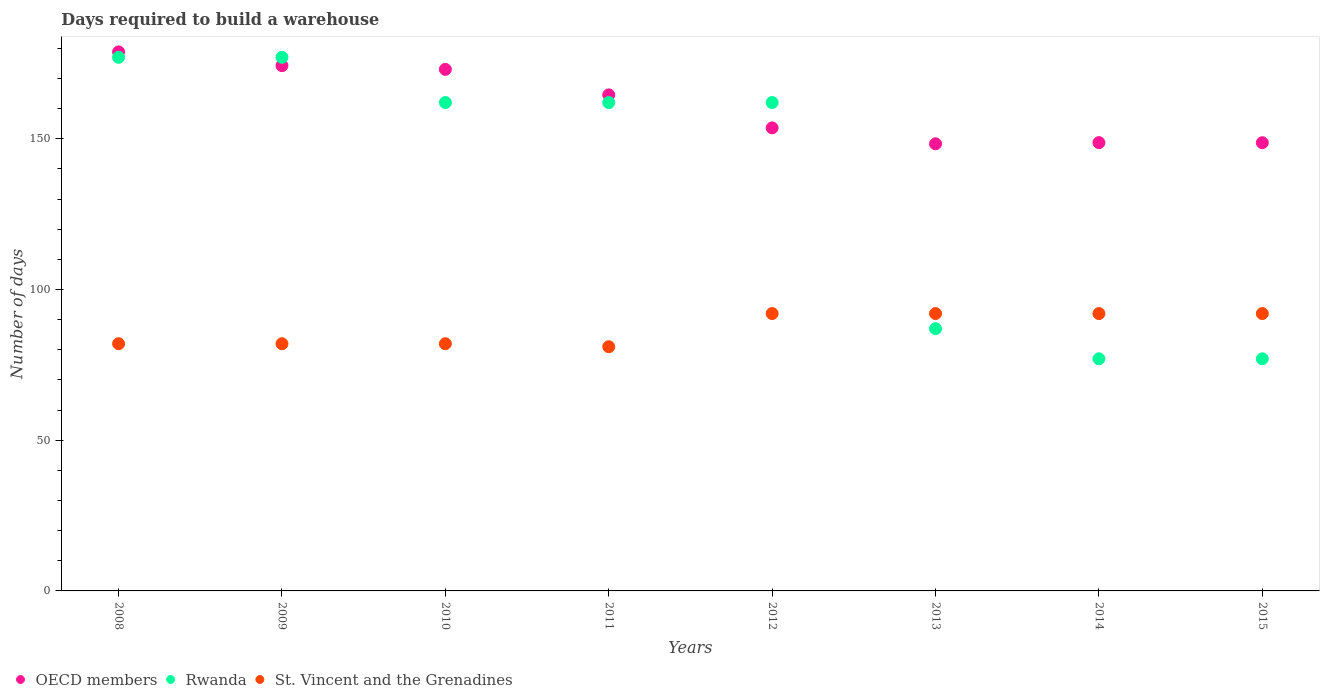Is the number of dotlines equal to the number of legend labels?
Your answer should be very brief. Yes. What is the days required to build a warehouse in in Rwanda in 2010?
Your answer should be compact. 162. Across all years, what is the maximum days required to build a warehouse in in OECD members?
Give a very brief answer. 178.79. Across all years, what is the minimum days required to build a warehouse in in St. Vincent and the Grenadines?
Keep it short and to the point. 81. In which year was the days required to build a warehouse in in OECD members maximum?
Provide a short and direct response. 2008. What is the total days required to build a warehouse in in St. Vincent and the Grenadines in the graph?
Make the answer very short. 695. What is the difference between the days required to build a warehouse in in St. Vincent and the Grenadines in 2009 and that in 2014?
Keep it short and to the point. -10. What is the difference between the days required to build a warehouse in in St. Vincent and the Grenadines in 2015 and the days required to build a warehouse in in OECD members in 2009?
Your response must be concise. -82.24. What is the average days required to build a warehouse in in OECD members per year?
Provide a short and direct response. 161.23. In the year 2009, what is the difference between the days required to build a warehouse in in St. Vincent and the Grenadines and days required to build a warehouse in in Rwanda?
Keep it short and to the point. -95. What is the ratio of the days required to build a warehouse in in Rwanda in 2008 to that in 2014?
Ensure brevity in your answer.  2.3. What is the difference between the highest and the second highest days required to build a warehouse in in OECD members?
Provide a short and direct response. 4.55. What is the difference between the highest and the lowest days required to build a warehouse in in Rwanda?
Offer a very short reply. 100. Is the sum of the days required to build a warehouse in in St. Vincent and the Grenadines in 2013 and 2015 greater than the maximum days required to build a warehouse in in OECD members across all years?
Provide a short and direct response. Yes. Does the days required to build a warehouse in in St. Vincent and the Grenadines monotonically increase over the years?
Your answer should be very brief. No. Is the days required to build a warehouse in in St. Vincent and the Grenadines strictly greater than the days required to build a warehouse in in Rwanda over the years?
Your answer should be very brief. No. How many dotlines are there?
Give a very brief answer. 3. What is the difference between two consecutive major ticks on the Y-axis?
Your answer should be compact. 50. Are the values on the major ticks of Y-axis written in scientific E-notation?
Your answer should be very brief. No. Where does the legend appear in the graph?
Offer a very short reply. Bottom left. How many legend labels are there?
Ensure brevity in your answer.  3. How are the legend labels stacked?
Provide a short and direct response. Horizontal. What is the title of the graph?
Your answer should be very brief. Days required to build a warehouse. Does "Micronesia" appear as one of the legend labels in the graph?
Your answer should be very brief. No. What is the label or title of the X-axis?
Your answer should be very brief. Years. What is the label or title of the Y-axis?
Your response must be concise. Number of days. What is the Number of days of OECD members in 2008?
Your response must be concise. 178.79. What is the Number of days in Rwanda in 2008?
Keep it short and to the point. 177. What is the Number of days of OECD members in 2009?
Ensure brevity in your answer.  174.24. What is the Number of days of Rwanda in 2009?
Make the answer very short. 177. What is the Number of days of OECD members in 2010?
Offer a very short reply. 173. What is the Number of days of Rwanda in 2010?
Provide a succinct answer. 162. What is the Number of days in St. Vincent and the Grenadines in 2010?
Offer a terse response. 82. What is the Number of days of OECD members in 2011?
Ensure brevity in your answer.  164.55. What is the Number of days of Rwanda in 2011?
Your response must be concise. 162. What is the Number of days in St. Vincent and the Grenadines in 2011?
Your response must be concise. 81. What is the Number of days in OECD members in 2012?
Your answer should be compact. 153.6. What is the Number of days in Rwanda in 2012?
Offer a very short reply. 162. What is the Number of days of St. Vincent and the Grenadines in 2012?
Your response must be concise. 92. What is the Number of days of OECD members in 2013?
Your answer should be very brief. 148.31. What is the Number of days of Rwanda in 2013?
Keep it short and to the point. 87. What is the Number of days in St. Vincent and the Grenadines in 2013?
Keep it short and to the point. 92. What is the Number of days in OECD members in 2014?
Give a very brief answer. 148.71. What is the Number of days of St. Vincent and the Grenadines in 2014?
Make the answer very short. 92. What is the Number of days of OECD members in 2015?
Provide a short and direct response. 148.68. What is the Number of days of St. Vincent and the Grenadines in 2015?
Offer a very short reply. 92. Across all years, what is the maximum Number of days of OECD members?
Ensure brevity in your answer.  178.79. Across all years, what is the maximum Number of days of Rwanda?
Keep it short and to the point. 177. Across all years, what is the maximum Number of days of St. Vincent and the Grenadines?
Your answer should be compact. 92. Across all years, what is the minimum Number of days in OECD members?
Your answer should be compact. 148.31. Across all years, what is the minimum Number of days in St. Vincent and the Grenadines?
Provide a succinct answer. 81. What is the total Number of days in OECD members in the graph?
Your answer should be very brief. 1289.87. What is the total Number of days in Rwanda in the graph?
Ensure brevity in your answer.  1081. What is the total Number of days of St. Vincent and the Grenadines in the graph?
Make the answer very short. 695. What is the difference between the Number of days of OECD members in 2008 and that in 2009?
Make the answer very short. 4.55. What is the difference between the Number of days of OECD members in 2008 and that in 2010?
Provide a short and direct response. 5.79. What is the difference between the Number of days in OECD members in 2008 and that in 2011?
Make the answer very short. 14.24. What is the difference between the Number of days of Rwanda in 2008 and that in 2011?
Keep it short and to the point. 15. What is the difference between the Number of days of OECD members in 2008 and that in 2012?
Offer a very short reply. 25.19. What is the difference between the Number of days of Rwanda in 2008 and that in 2012?
Your answer should be compact. 15. What is the difference between the Number of days in OECD members in 2008 and that in 2013?
Ensure brevity in your answer.  30.48. What is the difference between the Number of days of Rwanda in 2008 and that in 2013?
Make the answer very short. 90. What is the difference between the Number of days of St. Vincent and the Grenadines in 2008 and that in 2013?
Your response must be concise. -10. What is the difference between the Number of days of OECD members in 2008 and that in 2014?
Offer a terse response. 30.08. What is the difference between the Number of days in Rwanda in 2008 and that in 2014?
Make the answer very short. 100. What is the difference between the Number of days of St. Vincent and the Grenadines in 2008 and that in 2014?
Provide a succinct answer. -10. What is the difference between the Number of days in OECD members in 2008 and that in 2015?
Keep it short and to the point. 30.11. What is the difference between the Number of days of St. Vincent and the Grenadines in 2008 and that in 2015?
Offer a terse response. -10. What is the difference between the Number of days in OECD members in 2009 and that in 2010?
Give a very brief answer. 1.24. What is the difference between the Number of days of Rwanda in 2009 and that in 2010?
Your answer should be compact. 15. What is the difference between the Number of days of OECD members in 2009 and that in 2011?
Your answer should be compact. 9.69. What is the difference between the Number of days in Rwanda in 2009 and that in 2011?
Give a very brief answer. 15. What is the difference between the Number of days in St. Vincent and the Grenadines in 2009 and that in 2011?
Provide a short and direct response. 1. What is the difference between the Number of days in OECD members in 2009 and that in 2012?
Offer a very short reply. 20.65. What is the difference between the Number of days in St. Vincent and the Grenadines in 2009 and that in 2012?
Provide a short and direct response. -10. What is the difference between the Number of days in OECD members in 2009 and that in 2013?
Keep it short and to the point. 25.93. What is the difference between the Number of days in St. Vincent and the Grenadines in 2009 and that in 2013?
Provide a succinct answer. -10. What is the difference between the Number of days in OECD members in 2009 and that in 2014?
Offer a terse response. 25.54. What is the difference between the Number of days in Rwanda in 2009 and that in 2014?
Ensure brevity in your answer.  100. What is the difference between the Number of days of St. Vincent and the Grenadines in 2009 and that in 2014?
Ensure brevity in your answer.  -10. What is the difference between the Number of days of OECD members in 2009 and that in 2015?
Your answer should be very brief. 25.57. What is the difference between the Number of days of OECD members in 2010 and that in 2011?
Provide a short and direct response. 8.45. What is the difference between the Number of days of Rwanda in 2010 and that in 2011?
Your response must be concise. 0. What is the difference between the Number of days in St. Vincent and the Grenadines in 2010 and that in 2011?
Give a very brief answer. 1. What is the difference between the Number of days in OECD members in 2010 and that in 2012?
Your answer should be compact. 19.4. What is the difference between the Number of days in OECD members in 2010 and that in 2013?
Your answer should be very brief. 24.69. What is the difference between the Number of days in St. Vincent and the Grenadines in 2010 and that in 2013?
Ensure brevity in your answer.  -10. What is the difference between the Number of days of OECD members in 2010 and that in 2014?
Offer a very short reply. 24.29. What is the difference between the Number of days of Rwanda in 2010 and that in 2014?
Provide a succinct answer. 85. What is the difference between the Number of days in St. Vincent and the Grenadines in 2010 and that in 2014?
Your response must be concise. -10. What is the difference between the Number of days in OECD members in 2010 and that in 2015?
Your answer should be compact. 24.32. What is the difference between the Number of days of OECD members in 2011 and that in 2012?
Make the answer very short. 10.95. What is the difference between the Number of days of Rwanda in 2011 and that in 2012?
Make the answer very short. 0. What is the difference between the Number of days of OECD members in 2011 and that in 2013?
Give a very brief answer. 16.24. What is the difference between the Number of days of OECD members in 2011 and that in 2014?
Provide a succinct answer. 15.84. What is the difference between the Number of days of Rwanda in 2011 and that in 2014?
Provide a succinct answer. 85. What is the difference between the Number of days in OECD members in 2011 and that in 2015?
Provide a short and direct response. 15.87. What is the difference between the Number of days of St. Vincent and the Grenadines in 2011 and that in 2015?
Ensure brevity in your answer.  -11. What is the difference between the Number of days of OECD members in 2012 and that in 2013?
Your answer should be compact. 5.29. What is the difference between the Number of days of Rwanda in 2012 and that in 2013?
Keep it short and to the point. 75. What is the difference between the Number of days of OECD members in 2012 and that in 2014?
Your answer should be compact. 4.89. What is the difference between the Number of days in OECD members in 2012 and that in 2015?
Give a very brief answer. 4.92. What is the difference between the Number of days in Rwanda in 2012 and that in 2015?
Provide a short and direct response. 85. What is the difference between the Number of days in St. Vincent and the Grenadines in 2012 and that in 2015?
Keep it short and to the point. 0. What is the difference between the Number of days in OECD members in 2013 and that in 2014?
Your answer should be compact. -0.4. What is the difference between the Number of days in Rwanda in 2013 and that in 2014?
Make the answer very short. 10. What is the difference between the Number of days of OECD members in 2013 and that in 2015?
Your answer should be very brief. -0.37. What is the difference between the Number of days in Rwanda in 2013 and that in 2015?
Your response must be concise. 10. What is the difference between the Number of days of St. Vincent and the Grenadines in 2013 and that in 2015?
Make the answer very short. 0. What is the difference between the Number of days of OECD members in 2014 and that in 2015?
Give a very brief answer. 0.03. What is the difference between the Number of days in Rwanda in 2014 and that in 2015?
Your answer should be compact. 0. What is the difference between the Number of days in St. Vincent and the Grenadines in 2014 and that in 2015?
Make the answer very short. 0. What is the difference between the Number of days in OECD members in 2008 and the Number of days in Rwanda in 2009?
Offer a terse response. 1.79. What is the difference between the Number of days of OECD members in 2008 and the Number of days of St. Vincent and the Grenadines in 2009?
Offer a terse response. 96.79. What is the difference between the Number of days in OECD members in 2008 and the Number of days in Rwanda in 2010?
Ensure brevity in your answer.  16.79. What is the difference between the Number of days in OECD members in 2008 and the Number of days in St. Vincent and the Grenadines in 2010?
Your answer should be compact. 96.79. What is the difference between the Number of days of OECD members in 2008 and the Number of days of Rwanda in 2011?
Provide a short and direct response. 16.79. What is the difference between the Number of days of OECD members in 2008 and the Number of days of St. Vincent and the Grenadines in 2011?
Your response must be concise. 97.79. What is the difference between the Number of days of Rwanda in 2008 and the Number of days of St. Vincent and the Grenadines in 2011?
Your answer should be very brief. 96. What is the difference between the Number of days of OECD members in 2008 and the Number of days of Rwanda in 2012?
Your answer should be very brief. 16.79. What is the difference between the Number of days of OECD members in 2008 and the Number of days of St. Vincent and the Grenadines in 2012?
Your response must be concise. 86.79. What is the difference between the Number of days of Rwanda in 2008 and the Number of days of St. Vincent and the Grenadines in 2012?
Provide a short and direct response. 85. What is the difference between the Number of days of OECD members in 2008 and the Number of days of Rwanda in 2013?
Your answer should be very brief. 91.79. What is the difference between the Number of days in OECD members in 2008 and the Number of days in St. Vincent and the Grenadines in 2013?
Give a very brief answer. 86.79. What is the difference between the Number of days in OECD members in 2008 and the Number of days in Rwanda in 2014?
Provide a succinct answer. 101.79. What is the difference between the Number of days in OECD members in 2008 and the Number of days in St. Vincent and the Grenadines in 2014?
Give a very brief answer. 86.79. What is the difference between the Number of days of Rwanda in 2008 and the Number of days of St. Vincent and the Grenadines in 2014?
Give a very brief answer. 85. What is the difference between the Number of days of OECD members in 2008 and the Number of days of Rwanda in 2015?
Make the answer very short. 101.79. What is the difference between the Number of days in OECD members in 2008 and the Number of days in St. Vincent and the Grenadines in 2015?
Offer a very short reply. 86.79. What is the difference between the Number of days in Rwanda in 2008 and the Number of days in St. Vincent and the Grenadines in 2015?
Your answer should be very brief. 85. What is the difference between the Number of days of OECD members in 2009 and the Number of days of Rwanda in 2010?
Ensure brevity in your answer.  12.24. What is the difference between the Number of days of OECD members in 2009 and the Number of days of St. Vincent and the Grenadines in 2010?
Offer a terse response. 92.24. What is the difference between the Number of days of OECD members in 2009 and the Number of days of Rwanda in 2011?
Provide a short and direct response. 12.24. What is the difference between the Number of days of OECD members in 2009 and the Number of days of St. Vincent and the Grenadines in 2011?
Your response must be concise. 93.24. What is the difference between the Number of days in Rwanda in 2009 and the Number of days in St. Vincent and the Grenadines in 2011?
Keep it short and to the point. 96. What is the difference between the Number of days in OECD members in 2009 and the Number of days in Rwanda in 2012?
Provide a succinct answer. 12.24. What is the difference between the Number of days of OECD members in 2009 and the Number of days of St. Vincent and the Grenadines in 2012?
Your answer should be compact. 82.24. What is the difference between the Number of days of Rwanda in 2009 and the Number of days of St. Vincent and the Grenadines in 2012?
Provide a succinct answer. 85. What is the difference between the Number of days of OECD members in 2009 and the Number of days of Rwanda in 2013?
Ensure brevity in your answer.  87.24. What is the difference between the Number of days of OECD members in 2009 and the Number of days of St. Vincent and the Grenadines in 2013?
Your answer should be very brief. 82.24. What is the difference between the Number of days of Rwanda in 2009 and the Number of days of St. Vincent and the Grenadines in 2013?
Your answer should be compact. 85. What is the difference between the Number of days in OECD members in 2009 and the Number of days in Rwanda in 2014?
Provide a succinct answer. 97.24. What is the difference between the Number of days of OECD members in 2009 and the Number of days of St. Vincent and the Grenadines in 2014?
Your answer should be compact. 82.24. What is the difference between the Number of days in Rwanda in 2009 and the Number of days in St. Vincent and the Grenadines in 2014?
Offer a very short reply. 85. What is the difference between the Number of days in OECD members in 2009 and the Number of days in Rwanda in 2015?
Provide a short and direct response. 97.24. What is the difference between the Number of days in OECD members in 2009 and the Number of days in St. Vincent and the Grenadines in 2015?
Make the answer very short. 82.24. What is the difference between the Number of days of OECD members in 2010 and the Number of days of St. Vincent and the Grenadines in 2011?
Ensure brevity in your answer.  92. What is the difference between the Number of days of Rwanda in 2010 and the Number of days of St. Vincent and the Grenadines in 2011?
Keep it short and to the point. 81. What is the difference between the Number of days in OECD members in 2010 and the Number of days in Rwanda in 2012?
Give a very brief answer. 11. What is the difference between the Number of days of OECD members in 2010 and the Number of days of St. Vincent and the Grenadines in 2012?
Your answer should be compact. 81. What is the difference between the Number of days in OECD members in 2010 and the Number of days in Rwanda in 2013?
Give a very brief answer. 86. What is the difference between the Number of days in OECD members in 2010 and the Number of days in St. Vincent and the Grenadines in 2013?
Your response must be concise. 81. What is the difference between the Number of days in Rwanda in 2010 and the Number of days in St. Vincent and the Grenadines in 2013?
Give a very brief answer. 70. What is the difference between the Number of days of OECD members in 2010 and the Number of days of Rwanda in 2014?
Your answer should be very brief. 96. What is the difference between the Number of days in OECD members in 2010 and the Number of days in St. Vincent and the Grenadines in 2014?
Provide a short and direct response. 81. What is the difference between the Number of days of OECD members in 2010 and the Number of days of Rwanda in 2015?
Your answer should be very brief. 96. What is the difference between the Number of days of Rwanda in 2010 and the Number of days of St. Vincent and the Grenadines in 2015?
Ensure brevity in your answer.  70. What is the difference between the Number of days in OECD members in 2011 and the Number of days in Rwanda in 2012?
Provide a succinct answer. 2.55. What is the difference between the Number of days in OECD members in 2011 and the Number of days in St. Vincent and the Grenadines in 2012?
Offer a terse response. 72.55. What is the difference between the Number of days of OECD members in 2011 and the Number of days of Rwanda in 2013?
Your answer should be compact. 77.55. What is the difference between the Number of days in OECD members in 2011 and the Number of days in St. Vincent and the Grenadines in 2013?
Provide a short and direct response. 72.55. What is the difference between the Number of days in Rwanda in 2011 and the Number of days in St. Vincent and the Grenadines in 2013?
Keep it short and to the point. 70. What is the difference between the Number of days of OECD members in 2011 and the Number of days of Rwanda in 2014?
Make the answer very short. 87.55. What is the difference between the Number of days of OECD members in 2011 and the Number of days of St. Vincent and the Grenadines in 2014?
Your answer should be compact. 72.55. What is the difference between the Number of days of Rwanda in 2011 and the Number of days of St. Vincent and the Grenadines in 2014?
Offer a terse response. 70. What is the difference between the Number of days of OECD members in 2011 and the Number of days of Rwanda in 2015?
Provide a succinct answer. 87.55. What is the difference between the Number of days in OECD members in 2011 and the Number of days in St. Vincent and the Grenadines in 2015?
Offer a terse response. 72.55. What is the difference between the Number of days in Rwanda in 2011 and the Number of days in St. Vincent and the Grenadines in 2015?
Ensure brevity in your answer.  70. What is the difference between the Number of days of OECD members in 2012 and the Number of days of Rwanda in 2013?
Provide a succinct answer. 66.6. What is the difference between the Number of days of OECD members in 2012 and the Number of days of St. Vincent and the Grenadines in 2013?
Make the answer very short. 61.6. What is the difference between the Number of days of Rwanda in 2012 and the Number of days of St. Vincent and the Grenadines in 2013?
Your response must be concise. 70. What is the difference between the Number of days of OECD members in 2012 and the Number of days of Rwanda in 2014?
Make the answer very short. 76.6. What is the difference between the Number of days of OECD members in 2012 and the Number of days of St. Vincent and the Grenadines in 2014?
Make the answer very short. 61.6. What is the difference between the Number of days of Rwanda in 2012 and the Number of days of St. Vincent and the Grenadines in 2014?
Your answer should be compact. 70. What is the difference between the Number of days in OECD members in 2012 and the Number of days in Rwanda in 2015?
Your response must be concise. 76.6. What is the difference between the Number of days of OECD members in 2012 and the Number of days of St. Vincent and the Grenadines in 2015?
Your response must be concise. 61.6. What is the difference between the Number of days in OECD members in 2013 and the Number of days in Rwanda in 2014?
Provide a short and direct response. 71.31. What is the difference between the Number of days of OECD members in 2013 and the Number of days of St. Vincent and the Grenadines in 2014?
Offer a terse response. 56.31. What is the difference between the Number of days of Rwanda in 2013 and the Number of days of St. Vincent and the Grenadines in 2014?
Offer a very short reply. -5. What is the difference between the Number of days of OECD members in 2013 and the Number of days of Rwanda in 2015?
Make the answer very short. 71.31. What is the difference between the Number of days of OECD members in 2013 and the Number of days of St. Vincent and the Grenadines in 2015?
Offer a terse response. 56.31. What is the difference between the Number of days in Rwanda in 2013 and the Number of days in St. Vincent and the Grenadines in 2015?
Your response must be concise. -5. What is the difference between the Number of days in OECD members in 2014 and the Number of days in Rwanda in 2015?
Keep it short and to the point. 71.71. What is the difference between the Number of days in OECD members in 2014 and the Number of days in St. Vincent and the Grenadines in 2015?
Provide a succinct answer. 56.71. What is the average Number of days of OECD members per year?
Ensure brevity in your answer.  161.23. What is the average Number of days in Rwanda per year?
Make the answer very short. 135.12. What is the average Number of days in St. Vincent and the Grenadines per year?
Give a very brief answer. 86.88. In the year 2008, what is the difference between the Number of days in OECD members and Number of days in Rwanda?
Provide a short and direct response. 1.79. In the year 2008, what is the difference between the Number of days of OECD members and Number of days of St. Vincent and the Grenadines?
Your answer should be compact. 96.79. In the year 2008, what is the difference between the Number of days of Rwanda and Number of days of St. Vincent and the Grenadines?
Make the answer very short. 95. In the year 2009, what is the difference between the Number of days in OECD members and Number of days in Rwanda?
Your response must be concise. -2.76. In the year 2009, what is the difference between the Number of days of OECD members and Number of days of St. Vincent and the Grenadines?
Offer a very short reply. 92.24. In the year 2010, what is the difference between the Number of days of OECD members and Number of days of St. Vincent and the Grenadines?
Offer a terse response. 91. In the year 2010, what is the difference between the Number of days in Rwanda and Number of days in St. Vincent and the Grenadines?
Provide a short and direct response. 80. In the year 2011, what is the difference between the Number of days in OECD members and Number of days in Rwanda?
Make the answer very short. 2.55. In the year 2011, what is the difference between the Number of days in OECD members and Number of days in St. Vincent and the Grenadines?
Your answer should be very brief. 83.55. In the year 2011, what is the difference between the Number of days of Rwanda and Number of days of St. Vincent and the Grenadines?
Keep it short and to the point. 81. In the year 2012, what is the difference between the Number of days of OECD members and Number of days of Rwanda?
Your answer should be compact. -8.4. In the year 2012, what is the difference between the Number of days of OECD members and Number of days of St. Vincent and the Grenadines?
Your answer should be compact. 61.6. In the year 2013, what is the difference between the Number of days in OECD members and Number of days in Rwanda?
Provide a short and direct response. 61.31. In the year 2013, what is the difference between the Number of days of OECD members and Number of days of St. Vincent and the Grenadines?
Provide a short and direct response. 56.31. In the year 2014, what is the difference between the Number of days of OECD members and Number of days of Rwanda?
Your response must be concise. 71.71. In the year 2014, what is the difference between the Number of days of OECD members and Number of days of St. Vincent and the Grenadines?
Your response must be concise. 56.71. In the year 2014, what is the difference between the Number of days of Rwanda and Number of days of St. Vincent and the Grenadines?
Your answer should be very brief. -15. In the year 2015, what is the difference between the Number of days of OECD members and Number of days of Rwanda?
Your answer should be very brief. 71.68. In the year 2015, what is the difference between the Number of days of OECD members and Number of days of St. Vincent and the Grenadines?
Offer a very short reply. 56.68. What is the ratio of the Number of days in OECD members in 2008 to that in 2009?
Your answer should be very brief. 1.03. What is the ratio of the Number of days in Rwanda in 2008 to that in 2009?
Your response must be concise. 1. What is the ratio of the Number of days of St. Vincent and the Grenadines in 2008 to that in 2009?
Make the answer very short. 1. What is the ratio of the Number of days in OECD members in 2008 to that in 2010?
Your response must be concise. 1.03. What is the ratio of the Number of days in Rwanda in 2008 to that in 2010?
Your response must be concise. 1.09. What is the ratio of the Number of days in St. Vincent and the Grenadines in 2008 to that in 2010?
Give a very brief answer. 1. What is the ratio of the Number of days of OECD members in 2008 to that in 2011?
Provide a short and direct response. 1.09. What is the ratio of the Number of days in Rwanda in 2008 to that in 2011?
Your answer should be very brief. 1.09. What is the ratio of the Number of days in St. Vincent and the Grenadines in 2008 to that in 2011?
Offer a very short reply. 1.01. What is the ratio of the Number of days of OECD members in 2008 to that in 2012?
Offer a terse response. 1.16. What is the ratio of the Number of days in Rwanda in 2008 to that in 2012?
Offer a terse response. 1.09. What is the ratio of the Number of days of St. Vincent and the Grenadines in 2008 to that in 2012?
Your answer should be very brief. 0.89. What is the ratio of the Number of days of OECD members in 2008 to that in 2013?
Keep it short and to the point. 1.21. What is the ratio of the Number of days of Rwanda in 2008 to that in 2013?
Your answer should be compact. 2.03. What is the ratio of the Number of days in St. Vincent and the Grenadines in 2008 to that in 2013?
Keep it short and to the point. 0.89. What is the ratio of the Number of days in OECD members in 2008 to that in 2014?
Keep it short and to the point. 1.2. What is the ratio of the Number of days in Rwanda in 2008 to that in 2014?
Your answer should be compact. 2.3. What is the ratio of the Number of days in St. Vincent and the Grenadines in 2008 to that in 2014?
Give a very brief answer. 0.89. What is the ratio of the Number of days of OECD members in 2008 to that in 2015?
Keep it short and to the point. 1.2. What is the ratio of the Number of days in Rwanda in 2008 to that in 2015?
Offer a very short reply. 2.3. What is the ratio of the Number of days in St. Vincent and the Grenadines in 2008 to that in 2015?
Ensure brevity in your answer.  0.89. What is the ratio of the Number of days of OECD members in 2009 to that in 2010?
Provide a short and direct response. 1.01. What is the ratio of the Number of days in Rwanda in 2009 to that in 2010?
Keep it short and to the point. 1.09. What is the ratio of the Number of days of OECD members in 2009 to that in 2011?
Keep it short and to the point. 1.06. What is the ratio of the Number of days in Rwanda in 2009 to that in 2011?
Give a very brief answer. 1.09. What is the ratio of the Number of days of St. Vincent and the Grenadines in 2009 to that in 2011?
Make the answer very short. 1.01. What is the ratio of the Number of days of OECD members in 2009 to that in 2012?
Your answer should be very brief. 1.13. What is the ratio of the Number of days in Rwanda in 2009 to that in 2012?
Your answer should be compact. 1.09. What is the ratio of the Number of days in St. Vincent and the Grenadines in 2009 to that in 2012?
Your answer should be compact. 0.89. What is the ratio of the Number of days in OECD members in 2009 to that in 2013?
Provide a short and direct response. 1.17. What is the ratio of the Number of days of Rwanda in 2009 to that in 2013?
Provide a succinct answer. 2.03. What is the ratio of the Number of days of St. Vincent and the Grenadines in 2009 to that in 2013?
Make the answer very short. 0.89. What is the ratio of the Number of days in OECD members in 2009 to that in 2014?
Your answer should be very brief. 1.17. What is the ratio of the Number of days of Rwanda in 2009 to that in 2014?
Offer a very short reply. 2.3. What is the ratio of the Number of days in St. Vincent and the Grenadines in 2009 to that in 2014?
Your response must be concise. 0.89. What is the ratio of the Number of days in OECD members in 2009 to that in 2015?
Provide a succinct answer. 1.17. What is the ratio of the Number of days in Rwanda in 2009 to that in 2015?
Give a very brief answer. 2.3. What is the ratio of the Number of days in St. Vincent and the Grenadines in 2009 to that in 2015?
Offer a very short reply. 0.89. What is the ratio of the Number of days of OECD members in 2010 to that in 2011?
Offer a very short reply. 1.05. What is the ratio of the Number of days in Rwanda in 2010 to that in 2011?
Your answer should be very brief. 1. What is the ratio of the Number of days of St. Vincent and the Grenadines in 2010 to that in 2011?
Keep it short and to the point. 1.01. What is the ratio of the Number of days in OECD members in 2010 to that in 2012?
Provide a short and direct response. 1.13. What is the ratio of the Number of days in St. Vincent and the Grenadines in 2010 to that in 2012?
Ensure brevity in your answer.  0.89. What is the ratio of the Number of days of OECD members in 2010 to that in 2013?
Make the answer very short. 1.17. What is the ratio of the Number of days in Rwanda in 2010 to that in 2013?
Make the answer very short. 1.86. What is the ratio of the Number of days in St. Vincent and the Grenadines in 2010 to that in 2013?
Your response must be concise. 0.89. What is the ratio of the Number of days of OECD members in 2010 to that in 2014?
Provide a succinct answer. 1.16. What is the ratio of the Number of days in Rwanda in 2010 to that in 2014?
Offer a very short reply. 2.1. What is the ratio of the Number of days of St. Vincent and the Grenadines in 2010 to that in 2014?
Offer a terse response. 0.89. What is the ratio of the Number of days in OECD members in 2010 to that in 2015?
Offer a terse response. 1.16. What is the ratio of the Number of days of Rwanda in 2010 to that in 2015?
Give a very brief answer. 2.1. What is the ratio of the Number of days of St. Vincent and the Grenadines in 2010 to that in 2015?
Provide a succinct answer. 0.89. What is the ratio of the Number of days of OECD members in 2011 to that in 2012?
Provide a succinct answer. 1.07. What is the ratio of the Number of days of St. Vincent and the Grenadines in 2011 to that in 2012?
Provide a short and direct response. 0.88. What is the ratio of the Number of days of OECD members in 2011 to that in 2013?
Offer a very short reply. 1.11. What is the ratio of the Number of days in Rwanda in 2011 to that in 2013?
Provide a short and direct response. 1.86. What is the ratio of the Number of days of St. Vincent and the Grenadines in 2011 to that in 2013?
Make the answer very short. 0.88. What is the ratio of the Number of days in OECD members in 2011 to that in 2014?
Make the answer very short. 1.11. What is the ratio of the Number of days in Rwanda in 2011 to that in 2014?
Provide a short and direct response. 2.1. What is the ratio of the Number of days of St. Vincent and the Grenadines in 2011 to that in 2014?
Offer a terse response. 0.88. What is the ratio of the Number of days in OECD members in 2011 to that in 2015?
Keep it short and to the point. 1.11. What is the ratio of the Number of days in Rwanda in 2011 to that in 2015?
Ensure brevity in your answer.  2.1. What is the ratio of the Number of days of St. Vincent and the Grenadines in 2011 to that in 2015?
Provide a succinct answer. 0.88. What is the ratio of the Number of days in OECD members in 2012 to that in 2013?
Provide a short and direct response. 1.04. What is the ratio of the Number of days in Rwanda in 2012 to that in 2013?
Keep it short and to the point. 1.86. What is the ratio of the Number of days in OECD members in 2012 to that in 2014?
Provide a succinct answer. 1.03. What is the ratio of the Number of days of Rwanda in 2012 to that in 2014?
Your answer should be very brief. 2.1. What is the ratio of the Number of days of OECD members in 2012 to that in 2015?
Offer a very short reply. 1.03. What is the ratio of the Number of days of Rwanda in 2012 to that in 2015?
Offer a very short reply. 2.1. What is the ratio of the Number of days in OECD members in 2013 to that in 2014?
Provide a succinct answer. 1. What is the ratio of the Number of days of Rwanda in 2013 to that in 2014?
Offer a terse response. 1.13. What is the ratio of the Number of days of Rwanda in 2013 to that in 2015?
Offer a terse response. 1.13. What is the ratio of the Number of days of St. Vincent and the Grenadines in 2014 to that in 2015?
Offer a very short reply. 1. What is the difference between the highest and the second highest Number of days in OECD members?
Your answer should be compact. 4.55. What is the difference between the highest and the second highest Number of days of Rwanda?
Your answer should be very brief. 0. What is the difference between the highest and the lowest Number of days in OECD members?
Provide a succinct answer. 30.48. What is the difference between the highest and the lowest Number of days in Rwanda?
Offer a terse response. 100. 